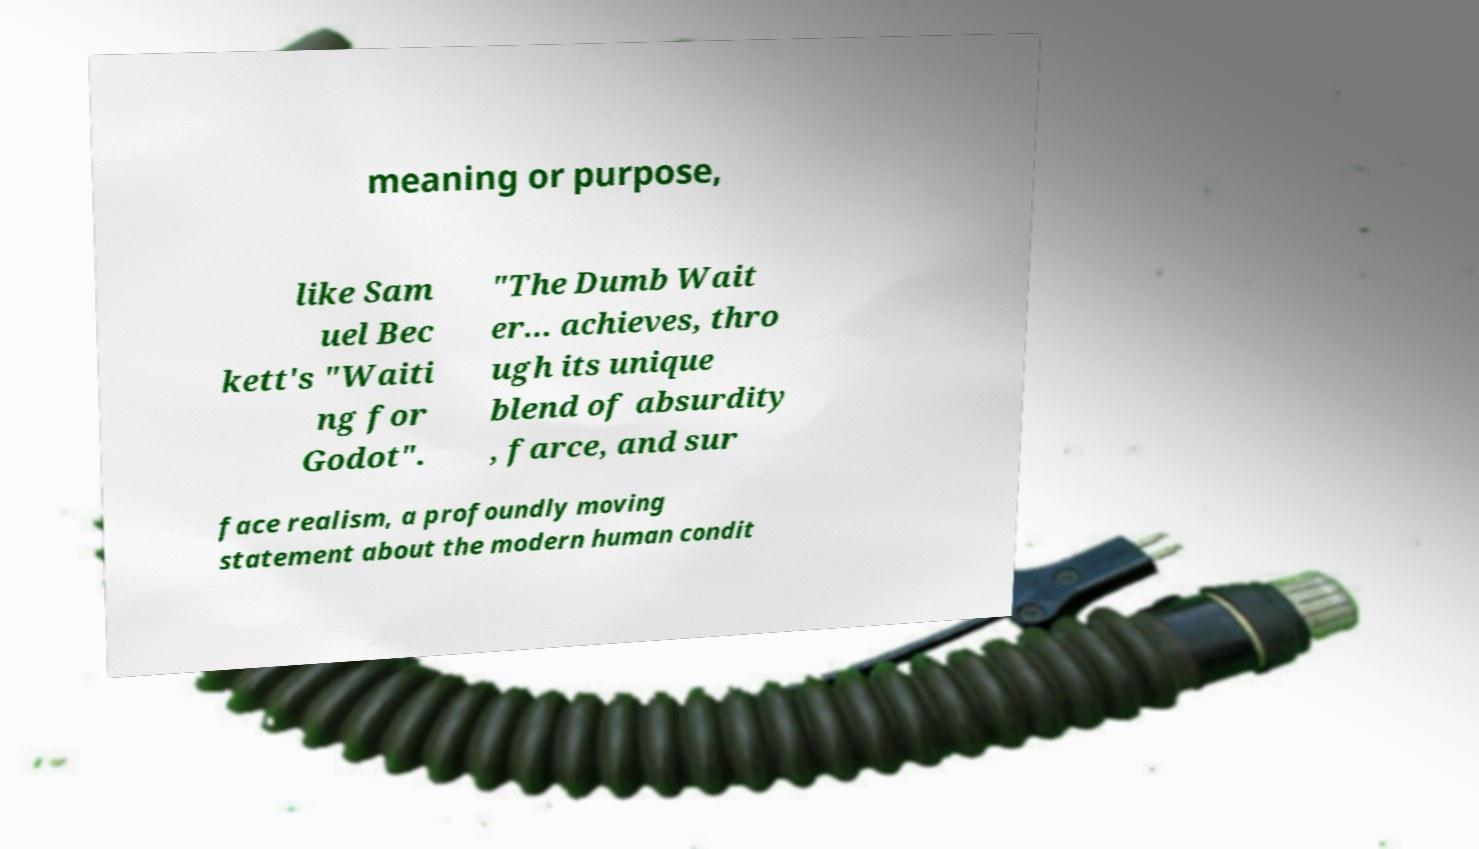Please identify and transcribe the text found in this image. meaning or purpose, like Sam uel Bec kett's "Waiti ng for Godot". "The Dumb Wait er... achieves, thro ugh its unique blend of absurdity , farce, and sur face realism, a profoundly moving statement about the modern human condit 